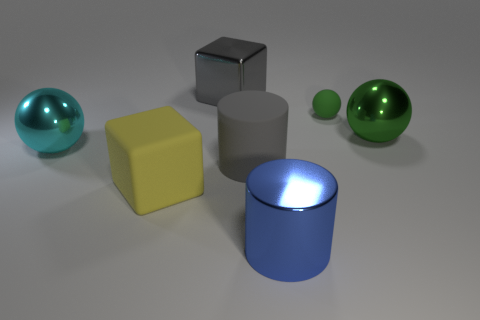Subtract 1 balls. How many balls are left? 2 Add 3 big shiny balls. How many objects exist? 10 Subtract all cylinders. How many objects are left? 5 Subtract all large cyan spheres. Subtract all big blue objects. How many objects are left? 5 Add 2 big cyan objects. How many big cyan objects are left? 3 Add 3 gray cylinders. How many gray cylinders exist? 4 Subtract 0 green cubes. How many objects are left? 7 